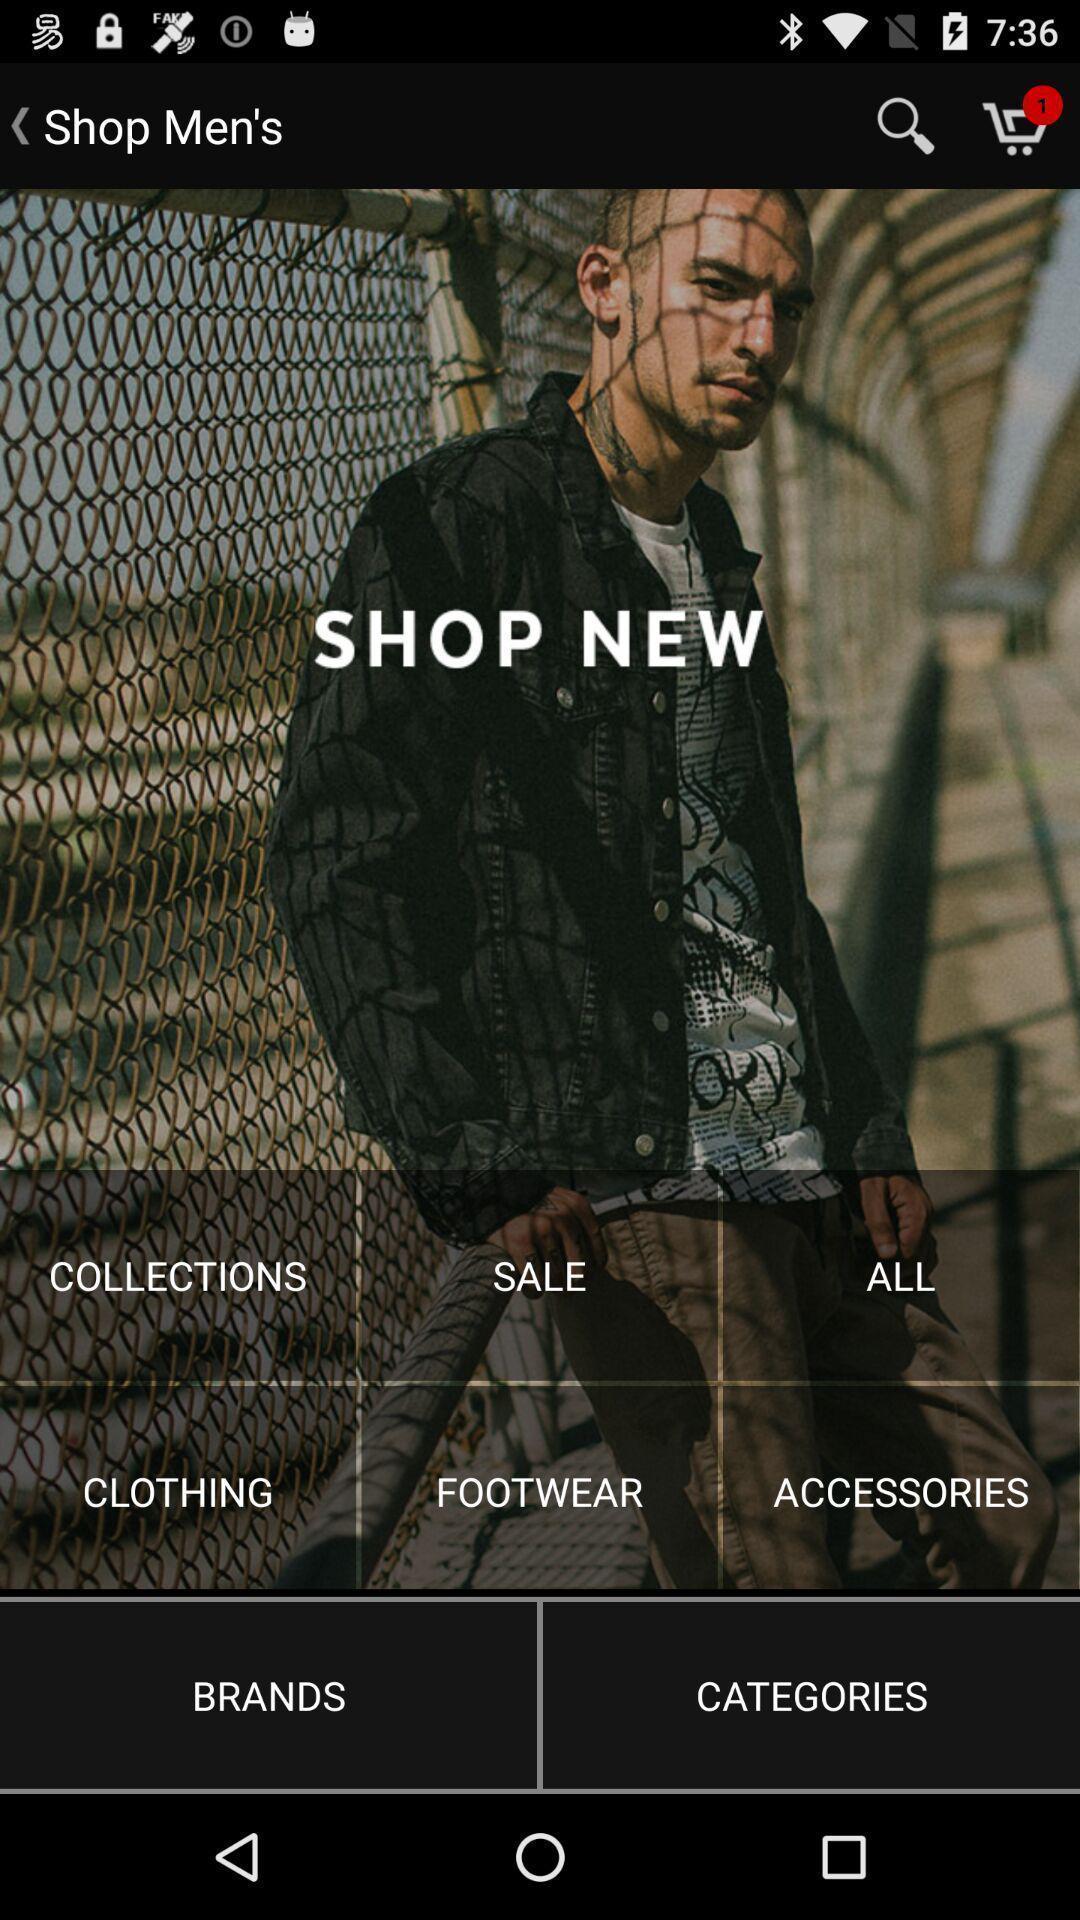Please provide a description for this image. Page of an online shopping application. 